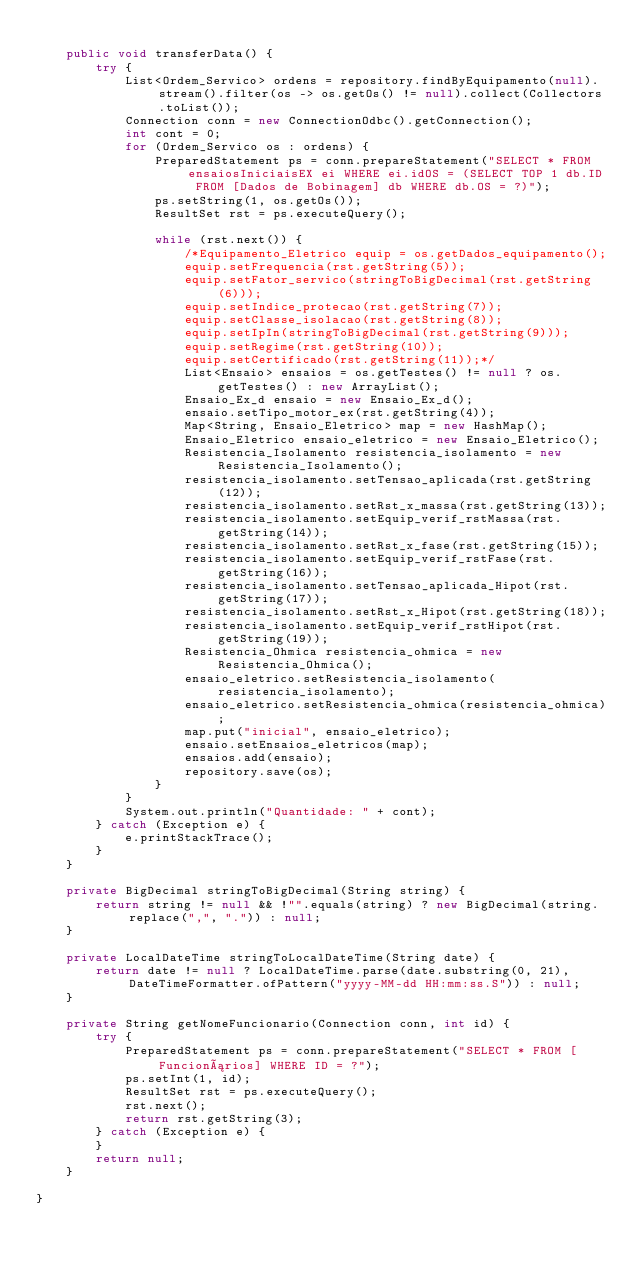<code> <loc_0><loc_0><loc_500><loc_500><_Java_>
    public void transferData() {
        try {
            List<Ordem_Servico> ordens = repository.findByEquipamento(null).stream().filter(os -> os.getOs() != null).collect(Collectors.toList());
            Connection conn = new ConnectionOdbc().getConnection();
            int cont = 0;
            for (Ordem_Servico os : ordens) {
                PreparedStatement ps = conn.prepareStatement("SELECT * FROM ensaiosIniciaisEX ei WHERE ei.idOS = (SELECT TOP 1 db.ID FROM [Dados de Bobinagem] db WHERE db.OS = ?)");
                ps.setString(1, os.getOs());
                ResultSet rst = ps.executeQuery();

                while (rst.next()) {
                    /*Equipamento_Eletrico equip = os.getDados_equipamento();
                    equip.setFrequencia(rst.getString(5));
                    equip.setFator_servico(stringToBigDecimal(rst.getString(6)));
                    equip.setIndice_protecao(rst.getString(7));
                    equip.setClasse_isolacao(rst.getString(8));
                    equip.setIpIn(stringToBigDecimal(rst.getString(9)));
                    equip.setRegime(rst.getString(10));
                    equip.setCertificado(rst.getString(11));*/
                    List<Ensaio> ensaios = os.getTestes() != null ? os.getTestes() : new ArrayList();
                    Ensaio_Ex_d ensaio = new Ensaio_Ex_d();
                    ensaio.setTipo_motor_ex(rst.getString(4));
                    Map<String, Ensaio_Eletrico> map = new HashMap();
                    Ensaio_Eletrico ensaio_eletrico = new Ensaio_Eletrico();
                    Resistencia_Isolamento resistencia_isolamento = new Resistencia_Isolamento();
                    resistencia_isolamento.setTensao_aplicada(rst.getString(12));
                    resistencia_isolamento.setRst_x_massa(rst.getString(13));
                    resistencia_isolamento.setEquip_verif_rstMassa(rst.getString(14));
                    resistencia_isolamento.setRst_x_fase(rst.getString(15));
                    resistencia_isolamento.setEquip_verif_rstFase(rst.getString(16));
                    resistencia_isolamento.setTensao_aplicada_Hipot(rst.getString(17));
                    resistencia_isolamento.setRst_x_Hipot(rst.getString(18));
                    resistencia_isolamento.setEquip_verif_rstHipot(rst.getString(19));
                    Resistencia_Ohmica resistencia_ohmica = new Resistencia_Ohmica();
                    ensaio_eletrico.setResistencia_isolamento(resistencia_isolamento);
                    ensaio_eletrico.setResistencia_ohmica(resistencia_ohmica);
                    map.put("inicial", ensaio_eletrico);
                    ensaio.setEnsaios_eletricos(map);
                    ensaios.add(ensaio);
                    repository.save(os);
                }
            }
            System.out.println("Quantidade: " + cont);
        } catch (Exception e) {
            e.printStackTrace();
        }
    }

    private BigDecimal stringToBigDecimal(String string) {
        return string != null && !"".equals(string) ? new BigDecimal(string.replace(",", ".")) : null;
    }

    private LocalDateTime stringToLocalDateTime(String date) {
        return date != null ? LocalDateTime.parse(date.substring(0, 21), DateTimeFormatter.ofPattern("yyyy-MM-dd HH:mm:ss.S")) : null;
    }

    private String getNomeFuncionario(Connection conn, int id) {
        try {
            PreparedStatement ps = conn.prepareStatement("SELECT * FROM [Funcionários] WHERE ID = ?");
            ps.setInt(1, id);
            ResultSet rst = ps.executeQuery();
            rst.next();
            return rst.getString(3);
        } catch (Exception e) {
        }
        return null;
    }

}
</code> 